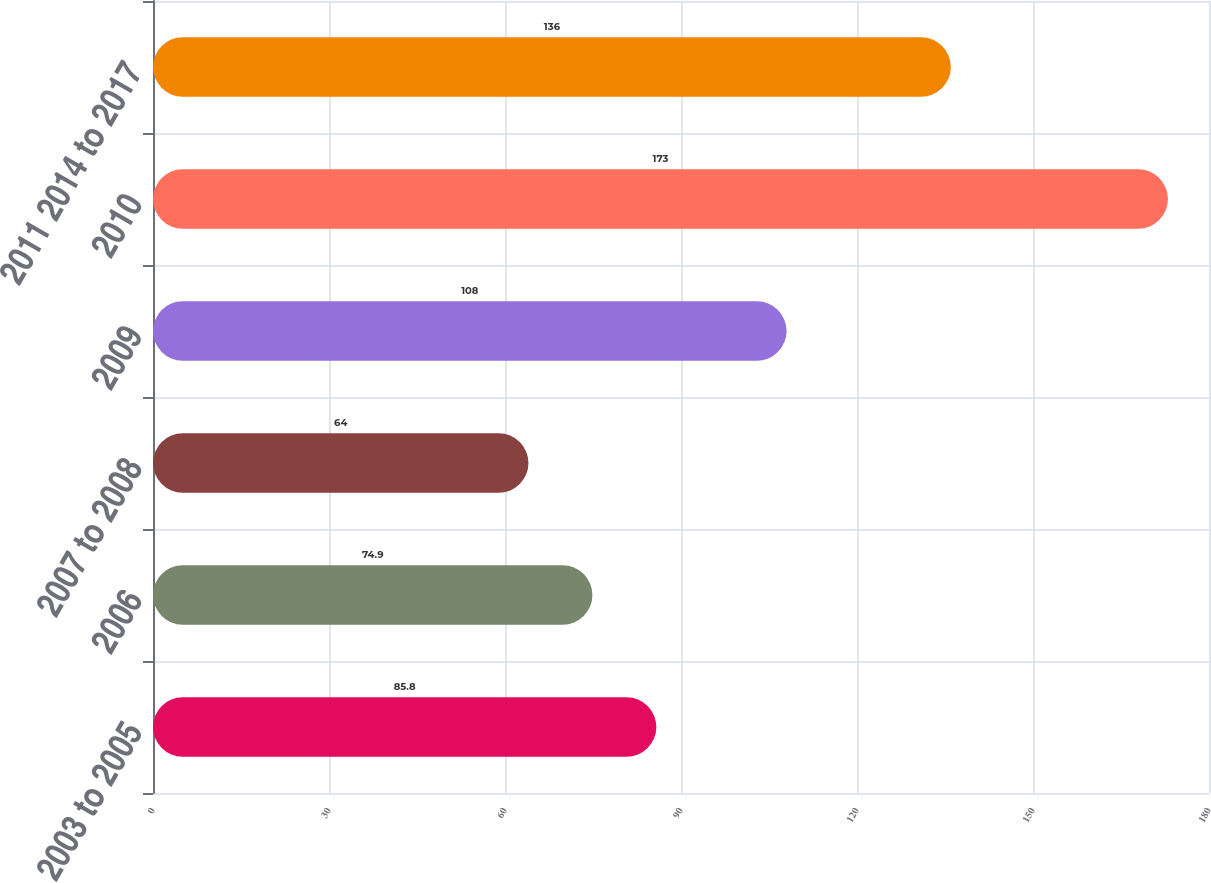<chart> <loc_0><loc_0><loc_500><loc_500><bar_chart><fcel>2003 to 2005<fcel>2006<fcel>2007 to 2008<fcel>2009<fcel>2010<fcel>2011 2014 to 2017<nl><fcel>85.8<fcel>74.9<fcel>64<fcel>108<fcel>173<fcel>136<nl></chart> 